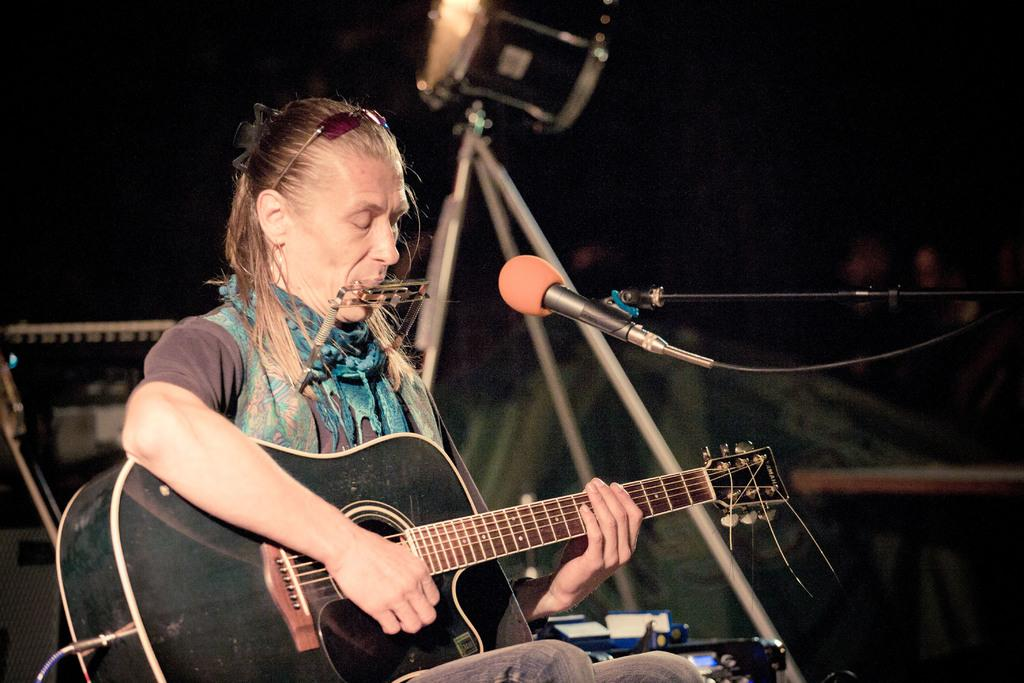What is the man in the image holding? The man is holding a guitar. What object is in front of the man? There is a microphone in front of the man. What might the man be doing in the image? The man might be performing or playing music, given that he is holding a guitar and there is a microphone in front of him. What type of collar is the man wearing in the image? There is no collar visible in the image, as the man is not wearing any clothing. 